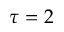Convert formula to latex. <formula><loc_0><loc_0><loc_500><loc_500>\tau = 2</formula> 